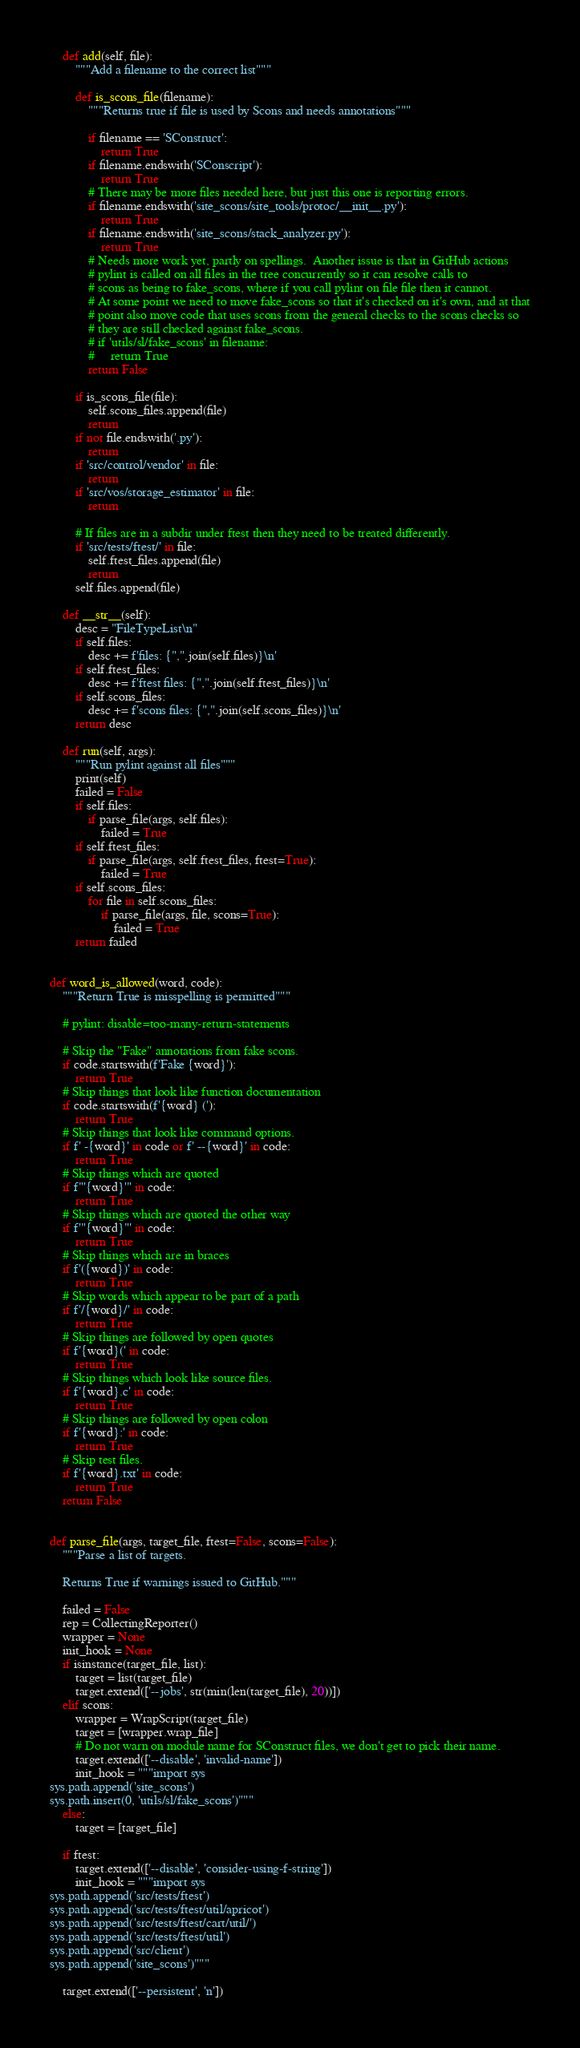<code> <loc_0><loc_0><loc_500><loc_500><_Python_>
    def add(self, file):
        """Add a filename to the correct list"""

        def is_scons_file(filename):
            """Returns true if file is used by Scons and needs annotations"""

            if filename == 'SConstruct':
                return True
            if filename.endswith('SConscript'):
                return True
            # There may be more files needed here, but just this one is reporting errors.
            if filename.endswith('site_scons/site_tools/protoc/__init__.py'):
                return True
            if filename.endswith('site_scons/stack_analyzer.py'):
                return True
            # Needs more work yet, partly on spellings.  Another issue is that in GitHub actions
            # pylint is called on all files in the tree concurrently so it can resolve calls to
            # scons as being to fake_scons, where if you call pylint on file file then it cannot.
            # At some point we need to move fake_scons so that it's checked on it's own, and at that
            # point also move code that uses scons from the general checks to the scons checks so
            # they are still checked against fake_scons.
            # if 'utils/sl/fake_scons' in filename:
            #     return True
            return False

        if is_scons_file(file):
            self.scons_files.append(file)
            return
        if not file.endswith('.py'):
            return
        if 'src/control/vendor' in file:
            return
        if 'src/vos/storage_estimator' in file:
            return

        # If files are in a subdir under ftest then they need to be treated differently.
        if 'src/tests/ftest/' in file:
            self.ftest_files.append(file)
            return
        self.files.append(file)

    def __str__(self):
        desc = "FileTypeList\n"
        if self.files:
            desc += f'files: {",".join(self.files)}\n'
        if self.ftest_files:
            desc += f'ftest files: {",".join(self.ftest_files)}\n'
        if self.scons_files:
            desc += f'scons files: {",".join(self.scons_files)}\n'
        return desc

    def run(self, args):
        """Run pylint against all files"""
        print(self)
        failed = False
        if self.files:
            if parse_file(args, self.files):
                failed = True
        if self.ftest_files:
            if parse_file(args, self.ftest_files, ftest=True):
                failed = True
        if self.scons_files:
            for file in self.scons_files:
                if parse_file(args, file, scons=True):
                    failed = True
        return failed


def word_is_allowed(word, code):
    """Return True is misspelling is permitted"""

    # pylint: disable=too-many-return-statements

    # Skip the "Fake" annotations from fake scons.
    if code.startswith(f'Fake {word}'):
        return True
    # Skip things that look like function documentation
    if code.startswith(f'{word} ('):
        return True
    # Skip things that look like command options.
    if f' -{word}' in code or f' --{word}' in code:
        return True
    # Skip things which are quoted
    if f"'{word}'" in code:
        return True
    # Skip things which are quoted the other way
    if f'"{word}"' in code:
        return True
    # Skip things which are in braces
    if f'({word})' in code:
        return True
    # Skip words which appear to be part of a path
    if f'/{word}/' in code:
        return True
    # Skip things are followed by open quotes
    if f'{word}(' in code:
        return True
    # Skip things which look like source files.
    if f'{word}.c' in code:
        return True
    # Skip things are followed by open colon
    if f'{word}:' in code:
        return True
    # Skip test files.
    if f'{word}.txt' in code:
        return True
    return False


def parse_file(args, target_file, ftest=False, scons=False):
    """Parse a list of targets.

    Returns True if warnings issued to GitHub."""

    failed = False
    rep = CollectingReporter()
    wrapper = None
    init_hook = None
    if isinstance(target_file, list):
        target = list(target_file)
        target.extend(['--jobs', str(min(len(target_file), 20))])
    elif scons:
        wrapper = WrapScript(target_file)
        target = [wrapper.wrap_file]
        # Do not warn on module name for SConstruct files, we don't get to pick their name.
        target.extend(['--disable', 'invalid-name'])
        init_hook = """import sys
sys.path.append('site_scons')
sys.path.insert(0, 'utils/sl/fake_scons')"""
    else:
        target = [target_file]

    if ftest:
        target.extend(['--disable', 'consider-using-f-string'])
        init_hook = """import sys
sys.path.append('src/tests/ftest')
sys.path.append('src/tests/ftest/util/apricot')
sys.path.append('src/tests/ftest/cart/util/')
sys.path.append('src/tests/ftest/util')
sys.path.append('src/client')
sys.path.append('site_scons')"""

    target.extend(['--persistent', 'n'])</code> 